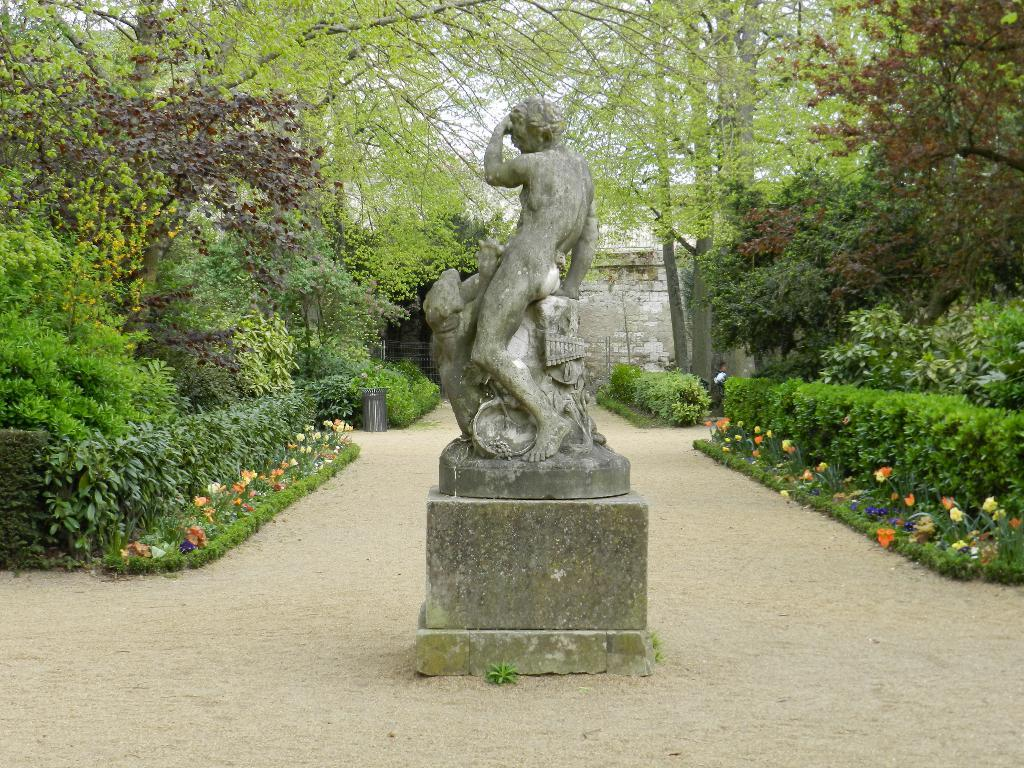What is the main subject in the middle of the image? There is a statue in the middle of the image. What else can be seen in the middle of the image besides the statue? There are bushes in the middle of the image. What type of vegetation is visible at the top of the image? There are trees at the top of the image. What type of yak can be seen grazing near the statue in the image? There is no yak present in the image; it only features a statue, bushes, and trees. 